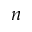Convert formula to latex. <formula><loc_0><loc_0><loc_500><loc_500>n</formula> 